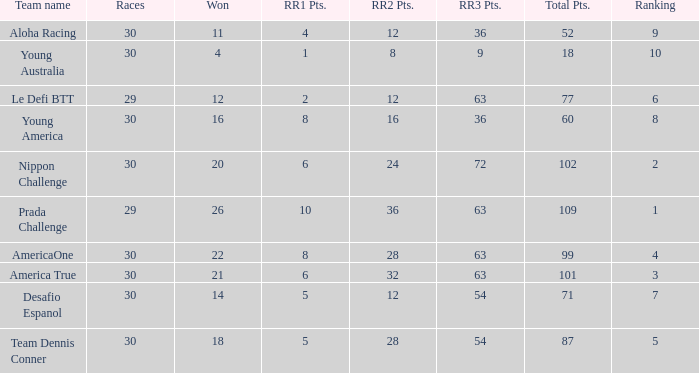Name the most rr1 pts for 7 ranking 5.0. 